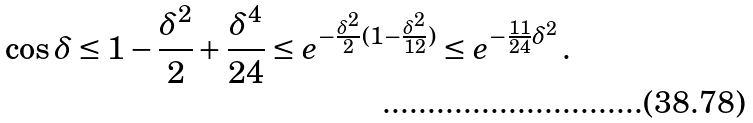Convert formula to latex. <formula><loc_0><loc_0><loc_500><loc_500>\cos \delta \leq 1 - \frac { \delta ^ { 2 } } { 2 } + \frac { \delta ^ { 4 } } { 2 4 } \leq e ^ { - \frac { \delta ^ { 2 } } { 2 } ( 1 - \frac { \delta ^ { 2 } } { 1 2 } ) } \leq e ^ { - \frac { 1 1 } { 2 4 } \delta ^ { 2 } } \, .</formula> 